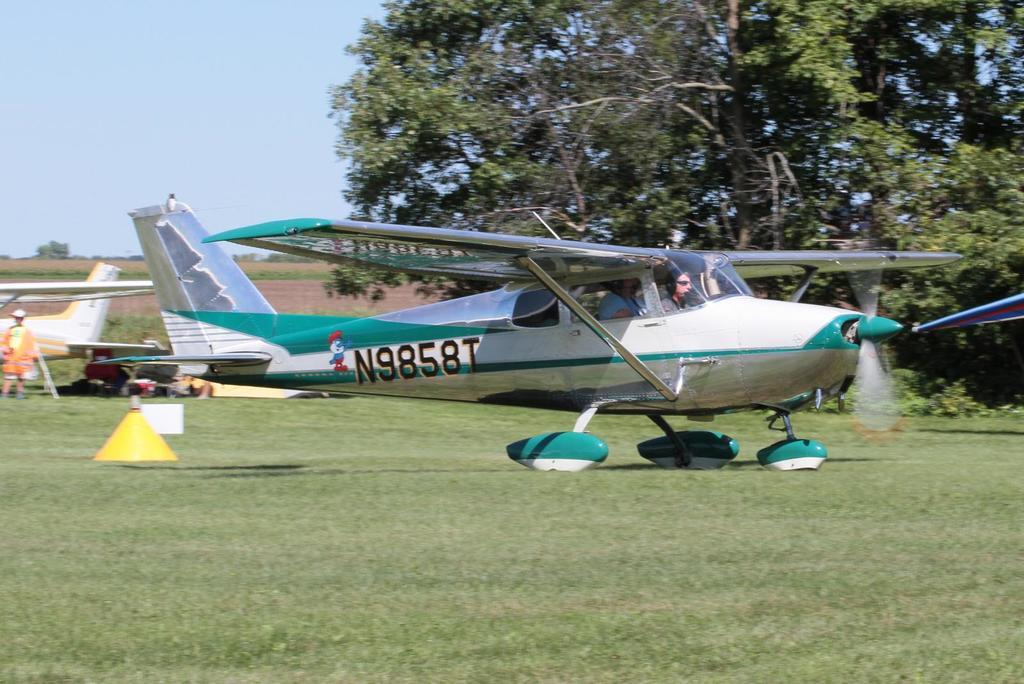<image>
Write a terse but informative summary of the picture. N9858T is the number of a plane parked on a grassy field. 